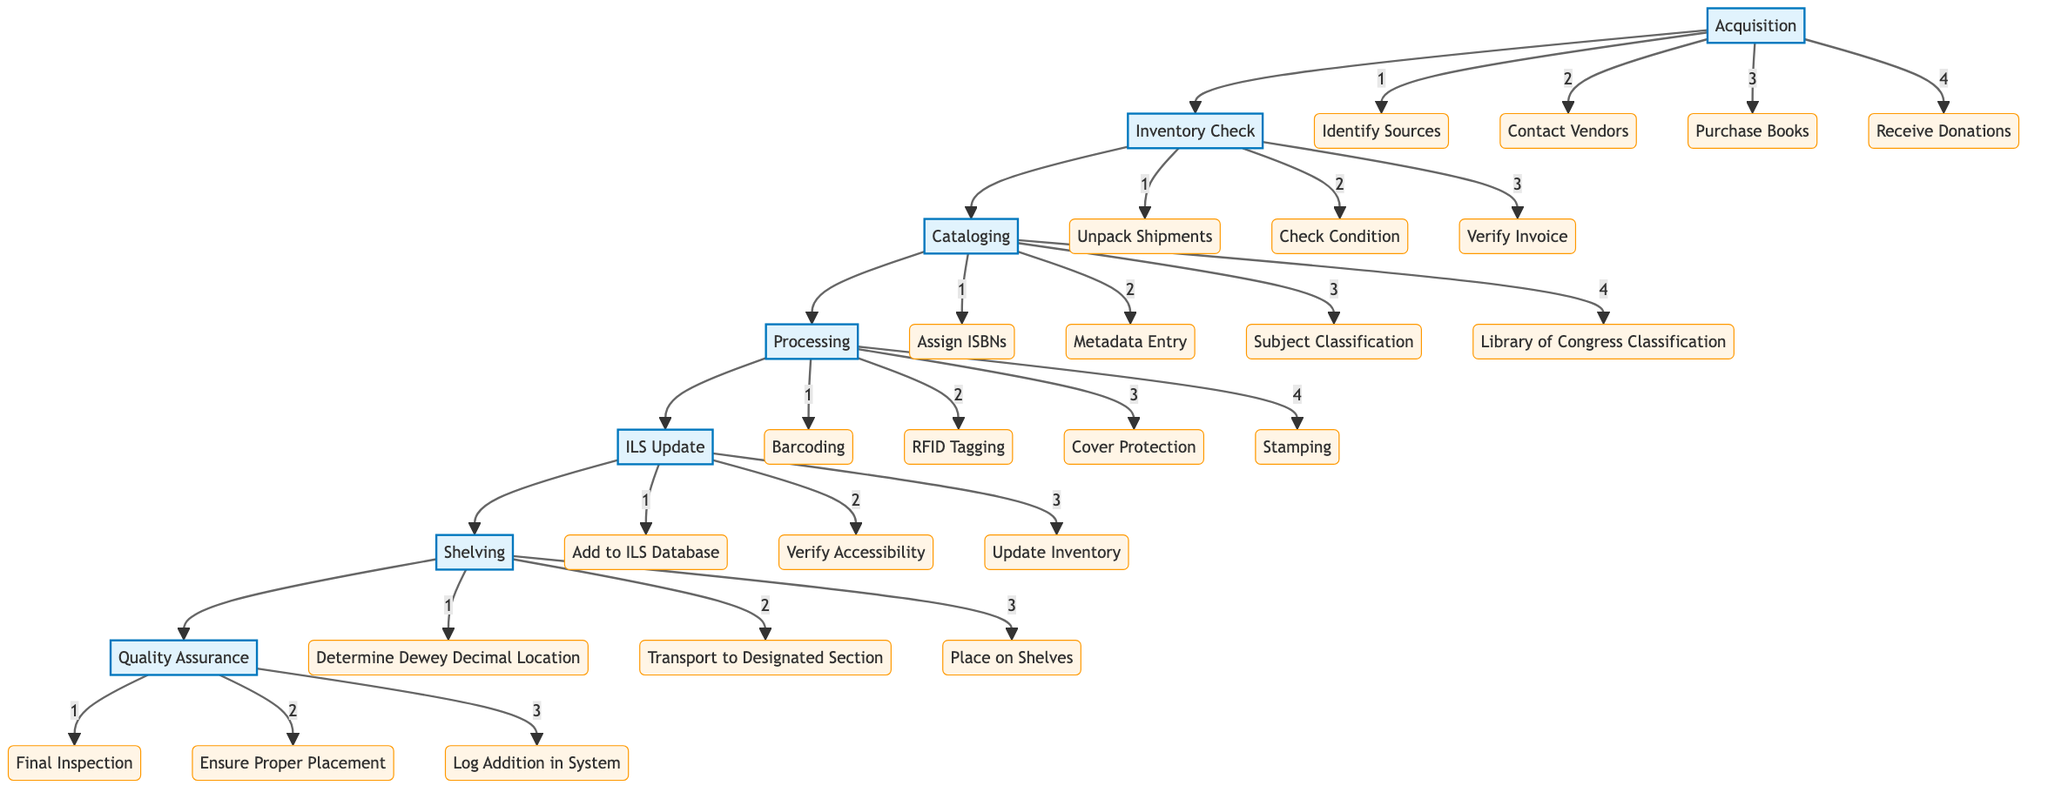What is the first step in the process? The first step in the flow chart is the "Acquisition" node, indicating that the cataloging process begins with acquiring new arrivals.
Answer: Acquisition How many sub-steps are there under the "Processing" stage? In the "Processing" stage, there are four sub-elements: Barcoding, RFID Tagging, Cover Protection, and Stamping, making a total of four.
Answer: 4 What follows the "Inventory Check" step? After the "Inventory Check" step, the next step in the flow chart is "Cataloging," showing the direct progression from checking inventory to cataloging the items.
Answer: Cataloging What is the last element in the flow? The last element in the flow chart is "Quality Assurance," which serves as the final step in ensuring that all previous processes have been completed correctly.
Answer: Quality Assurance Which step involves updating the library database? The step that involves updating the library database is "Integrated Library System (ILS) Update," which includes adding to the database and verifying accessibility.
Answer: Integrated Library System (ILS) Update How many main steps are there in the flow chart? The flow chart contains a total of six main steps: Acquisition, Inventory Check, Cataloging, Processing, ILS Update, Shelving, and Quality Assurance, resulting in seven main steps overall.
Answer: 7 What is the relationship between Cataloging and Processing? The relationship between "Cataloging" and "Processing" is sequential; "Processing" follows "Cataloging," indicating that processing occurs after cataloging has been completed.
Answer: Sequential Which two steps directly handle the physical items before they are placed on shelves? The two steps that directly handle the physical items before they are shelved are "Processing," which includes Barcoding and Cover Protection, and then "Shelving," where items are transported and placed on shelves.
Answer: Processing and Shelving What actions are taken before ILS Update? The actions taken before the "Integrated Library System (ILS) Update" are the "Processing" actions, which prepare the items for database entry by ensuring they are properly labeled and protected.
Answer: Processing actions 